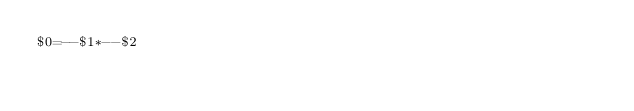<code> <loc_0><loc_0><loc_500><loc_500><_Awk_>$0=--$1*--$2</code> 